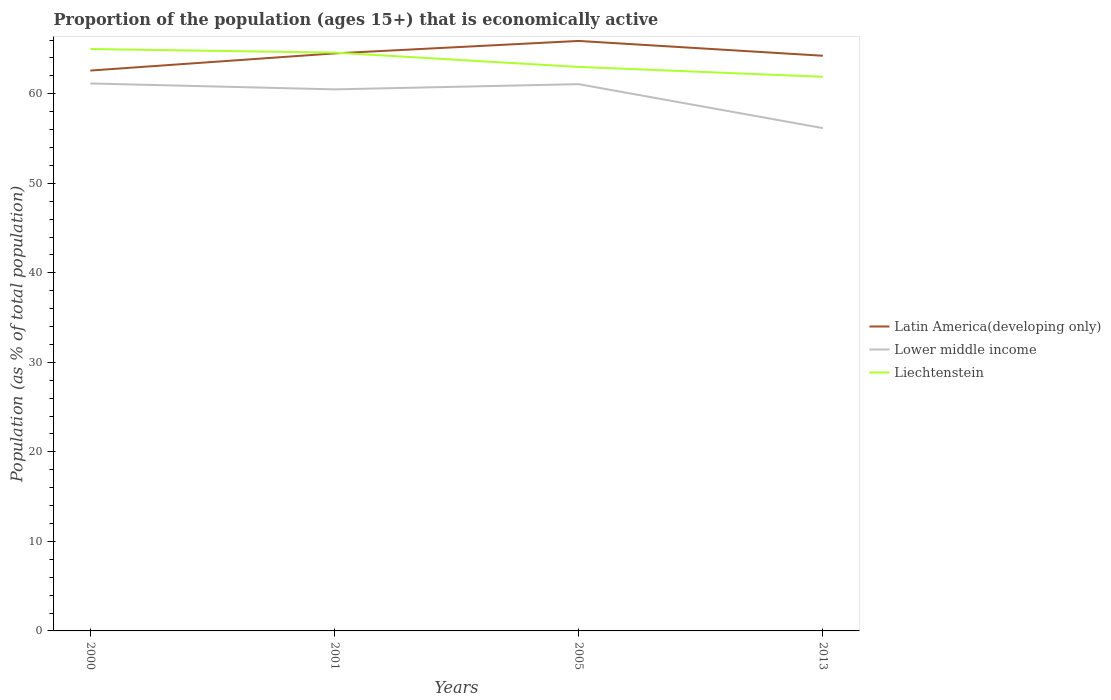Does the line corresponding to Lower middle income intersect with the line corresponding to Latin America(developing only)?
Give a very brief answer. No. Is the number of lines equal to the number of legend labels?
Make the answer very short. Yes. Across all years, what is the maximum proportion of the population that is economically active in Lower middle income?
Keep it short and to the point. 56.17. What is the total proportion of the population that is economically active in Lower middle income in the graph?
Your answer should be compact. -0.58. What is the difference between the highest and the second highest proportion of the population that is economically active in Liechtenstein?
Offer a very short reply. 3.1. How many years are there in the graph?
Your answer should be compact. 4. What is the difference between two consecutive major ticks on the Y-axis?
Keep it short and to the point. 10. Are the values on the major ticks of Y-axis written in scientific E-notation?
Offer a very short reply. No. Does the graph contain any zero values?
Your response must be concise. No. Where does the legend appear in the graph?
Provide a short and direct response. Center right. How are the legend labels stacked?
Provide a succinct answer. Vertical. What is the title of the graph?
Your answer should be compact. Proportion of the population (ages 15+) that is economically active. What is the label or title of the Y-axis?
Your answer should be very brief. Population (as % of total population). What is the Population (as % of total population) in Latin America(developing only) in 2000?
Your answer should be very brief. 62.59. What is the Population (as % of total population) of Lower middle income in 2000?
Keep it short and to the point. 61.15. What is the Population (as % of total population) of Liechtenstein in 2000?
Your answer should be very brief. 65. What is the Population (as % of total population) in Latin America(developing only) in 2001?
Give a very brief answer. 64.51. What is the Population (as % of total population) in Lower middle income in 2001?
Give a very brief answer. 60.49. What is the Population (as % of total population) in Liechtenstein in 2001?
Offer a terse response. 64.6. What is the Population (as % of total population) in Latin America(developing only) in 2005?
Your answer should be very brief. 65.9. What is the Population (as % of total population) in Lower middle income in 2005?
Provide a succinct answer. 61.07. What is the Population (as % of total population) in Latin America(developing only) in 2013?
Provide a succinct answer. 64.25. What is the Population (as % of total population) of Lower middle income in 2013?
Make the answer very short. 56.17. What is the Population (as % of total population) in Liechtenstein in 2013?
Your response must be concise. 61.9. Across all years, what is the maximum Population (as % of total population) in Latin America(developing only)?
Make the answer very short. 65.9. Across all years, what is the maximum Population (as % of total population) in Lower middle income?
Ensure brevity in your answer.  61.15. Across all years, what is the minimum Population (as % of total population) in Latin America(developing only)?
Give a very brief answer. 62.59. Across all years, what is the minimum Population (as % of total population) in Lower middle income?
Provide a succinct answer. 56.17. Across all years, what is the minimum Population (as % of total population) of Liechtenstein?
Your answer should be compact. 61.9. What is the total Population (as % of total population) in Latin America(developing only) in the graph?
Give a very brief answer. 257.26. What is the total Population (as % of total population) in Lower middle income in the graph?
Offer a very short reply. 238.89. What is the total Population (as % of total population) of Liechtenstein in the graph?
Your response must be concise. 254.5. What is the difference between the Population (as % of total population) of Latin America(developing only) in 2000 and that in 2001?
Make the answer very short. -1.92. What is the difference between the Population (as % of total population) of Lower middle income in 2000 and that in 2001?
Provide a short and direct response. 0.66. What is the difference between the Population (as % of total population) in Latin America(developing only) in 2000 and that in 2005?
Offer a very short reply. -3.31. What is the difference between the Population (as % of total population) of Lower middle income in 2000 and that in 2005?
Keep it short and to the point. 0.08. What is the difference between the Population (as % of total population) of Liechtenstein in 2000 and that in 2005?
Your response must be concise. 2. What is the difference between the Population (as % of total population) in Latin America(developing only) in 2000 and that in 2013?
Keep it short and to the point. -1.65. What is the difference between the Population (as % of total population) in Lower middle income in 2000 and that in 2013?
Provide a short and direct response. 4.99. What is the difference between the Population (as % of total population) of Latin America(developing only) in 2001 and that in 2005?
Provide a short and direct response. -1.39. What is the difference between the Population (as % of total population) in Lower middle income in 2001 and that in 2005?
Offer a terse response. -0.58. What is the difference between the Population (as % of total population) of Liechtenstein in 2001 and that in 2005?
Offer a terse response. 1.6. What is the difference between the Population (as % of total population) of Latin America(developing only) in 2001 and that in 2013?
Provide a succinct answer. 0.26. What is the difference between the Population (as % of total population) in Lower middle income in 2001 and that in 2013?
Ensure brevity in your answer.  4.33. What is the difference between the Population (as % of total population) of Liechtenstein in 2001 and that in 2013?
Ensure brevity in your answer.  2.7. What is the difference between the Population (as % of total population) in Latin America(developing only) in 2005 and that in 2013?
Your response must be concise. 1.65. What is the difference between the Population (as % of total population) in Lower middle income in 2005 and that in 2013?
Keep it short and to the point. 4.91. What is the difference between the Population (as % of total population) of Latin America(developing only) in 2000 and the Population (as % of total population) of Lower middle income in 2001?
Offer a very short reply. 2.1. What is the difference between the Population (as % of total population) of Latin America(developing only) in 2000 and the Population (as % of total population) of Liechtenstein in 2001?
Provide a short and direct response. -2. What is the difference between the Population (as % of total population) of Lower middle income in 2000 and the Population (as % of total population) of Liechtenstein in 2001?
Your response must be concise. -3.45. What is the difference between the Population (as % of total population) in Latin America(developing only) in 2000 and the Population (as % of total population) in Lower middle income in 2005?
Give a very brief answer. 1.52. What is the difference between the Population (as % of total population) in Latin America(developing only) in 2000 and the Population (as % of total population) in Liechtenstein in 2005?
Offer a terse response. -0.41. What is the difference between the Population (as % of total population) in Lower middle income in 2000 and the Population (as % of total population) in Liechtenstein in 2005?
Provide a short and direct response. -1.85. What is the difference between the Population (as % of total population) of Latin America(developing only) in 2000 and the Population (as % of total population) of Lower middle income in 2013?
Make the answer very short. 6.43. What is the difference between the Population (as % of total population) of Latin America(developing only) in 2000 and the Population (as % of total population) of Liechtenstein in 2013?
Your answer should be very brief. 0.69. What is the difference between the Population (as % of total population) in Lower middle income in 2000 and the Population (as % of total population) in Liechtenstein in 2013?
Offer a very short reply. -0.75. What is the difference between the Population (as % of total population) in Latin America(developing only) in 2001 and the Population (as % of total population) in Lower middle income in 2005?
Give a very brief answer. 3.44. What is the difference between the Population (as % of total population) of Latin America(developing only) in 2001 and the Population (as % of total population) of Liechtenstein in 2005?
Your answer should be very brief. 1.51. What is the difference between the Population (as % of total population) of Lower middle income in 2001 and the Population (as % of total population) of Liechtenstein in 2005?
Provide a succinct answer. -2.51. What is the difference between the Population (as % of total population) of Latin America(developing only) in 2001 and the Population (as % of total population) of Lower middle income in 2013?
Your answer should be very brief. 8.35. What is the difference between the Population (as % of total population) in Latin America(developing only) in 2001 and the Population (as % of total population) in Liechtenstein in 2013?
Your answer should be very brief. 2.61. What is the difference between the Population (as % of total population) in Lower middle income in 2001 and the Population (as % of total population) in Liechtenstein in 2013?
Offer a terse response. -1.41. What is the difference between the Population (as % of total population) in Latin America(developing only) in 2005 and the Population (as % of total population) in Lower middle income in 2013?
Your response must be concise. 9.74. What is the difference between the Population (as % of total population) of Latin America(developing only) in 2005 and the Population (as % of total population) of Liechtenstein in 2013?
Provide a short and direct response. 4. What is the difference between the Population (as % of total population) of Lower middle income in 2005 and the Population (as % of total population) of Liechtenstein in 2013?
Provide a succinct answer. -0.83. What is the average Population (as % of total population) of Latin America(developing only) per year?
Your answer should be very brief. 64.31. What is the average Population (as % of total population) in Lower middle income per year?
Your response must be concise. 59.72. What is the average Population (as % of total population) of Liechtenstein per year?
Provide a succinct answer. 63.62. In the year 2000, what is the difference between the Population (as % of total population) in Latin America(developing only) and Population (as % of total population) in Lower middle income?
Your answer should be very brief. 1.44. In the year 2000, what is the difference between the Population (as % of total population) of Latin America(developing only) and Population (as % of total population) of Liechtenstein?
Make the answer very short. -2.4. In the year 2000, what is the difference between the Population (as % of total population) in Lower middle income and Population (as % of total population) in Liechtenstein?
Keep it short and to the point. -3.85. In the year 2001, what is the difference between the Population (as % of total population) in Latin America(developing only) and Population (as % of total population) in Lower middle income?
Your answer should be compact. 4.02. In the year 2001, what is the difference between the Population (as % of total population) of Latin America(developing only) and Population (as % of total population) of Liechtenstein?
Offer a terse response. -0.09. In the year 2001, what is the difference between the Population (as % of total population) in Lower middle income and Population (as % of total population) in Liechtenstein?
Offer a very short reply. -4.11. In the year 2005, what is the difference between the Population (as % of total population) of Latin America(developing only) and Population (as % of total population) of Lower middle income?
Your answer should be compact. 4.83. In the year 2005, what is the difference between the Population (as % of total population) in Latin America(developing only) and Population (as % of total population) in Liechtenstein?
Provide a short and direct response. 2.9. In the year 2005, what is the difference between the Population (as % of total population) of Lower middle income and Population (as % of total population) of Liechtenstein?
Ensure brevity in your answer.  -1.93. In the year 2013, what is the difference between the Population (as % of total population) in Latin America(developing only) and Population (as % of total population) in Lower middle income?
Your answer should be very brief. 8.08. In the year 2013, what is the difference between the Population (as % of total population) of Latin America(developing only) and Population (as % of total population) of Liechtenstein?
Provide a succinct answer. 2.35. In the year 2013, what is the difference between the Population (as % of total population) in Lower middle income and Population (as % of total population) in Liechtenstein?
Keep it short and to the point. -5.73. What is the ratio of the Population (as % of total population) of Latin America(developing only) in 2000 to that in 2001?
Provide a short and direct response. 0.97. What is the ratio of the Population (as % of total population) of Lower middle income in 2000 to that in 2001?
Offer a terse response. 1.01. What is the ratio of the Population (as % of total population) of Liechtenstein in 2000 to that in 2001?
Offer a very short reply. 1.01. What is the ratio of the Population (as % of total population) in Latin America(developing only) in 2000 to that in 2005?
Ensure brevity in your answer.  0.95. What is the ratio of the Population (as % of total population) in Liechtenstein in 2000 to that in 2005?
Offer a very short reply. 1.03. What is the ratio of the Population (as % of total population) of Latin America(developing only) in 2000 to that in 2013?
Ensure brevity in your answer.  0.97. What is the ratio of the Population (as % of total population) in Lower middle income in 2000 to that in 2013?
Your response must be concise. 1.09. What is the ratio of the Population (as % of total population) in Liechtenstein in 2000 to that in 2013?
Your answer should be compact. 1.05. What is the ratio of the Population (as % of total population) of Latin America(developing only) in 2001 to that in 2005?
Make the answer very short. 0.98. What is the ratio of the Population (as % of total population) of Liechtenstein in 2001 to that in 2005?
Your response must be concise. 1.03. What is the ratio of the Population (as % of total population) in Latin America(developing only) in 2001 to that in 2013?
Offer a terse response. 1. What is the ratio of the Population (as % of total population) in Lower middle income in 2001 to that in 2013?
Your answer should be compact. 1.08. What is the ratio of the Population (as % of total population) of Liechtenstein in 2001 to that in 2013?
Provide a succinct answer. 1.04. What is the ratio of the Population (as % of total population) in Latin America(developing only) in 2005 to that in 2013?
Your answer should be compact. 1.03. What is the ratio of the Population (as % of total population) in Lower middle income in 2005 to that in 2013?
Provide a short and direct response. 1.09. What is the ratio of the Population (as % of total population) of Liechtenstein in 2005 to that in 2013?
Offer a very short reply. 1.02. What is the difference between the highest and the second highest Population (as % of total population) in Latin America(developing only)?
Offer a very short reply. 1.39. What is the difference between the highest and the second highest Population (as % of total population) in Lower middle income?
Your answer should be very brief. 0.08. What is the difference between the highest and the lowest Population (as % of total population) of Latin America(developing only)?
Ensure brevity in your answer.  3.31. What is the difference between the highest and the lowest Population (as % of total population) in Lower middle income?
Offer a very short reply. 4.99. What is the difference between the highest and the lowest Population (as % of total population) in Liechtenstein?
Your answer should be very brief. 3.1. 